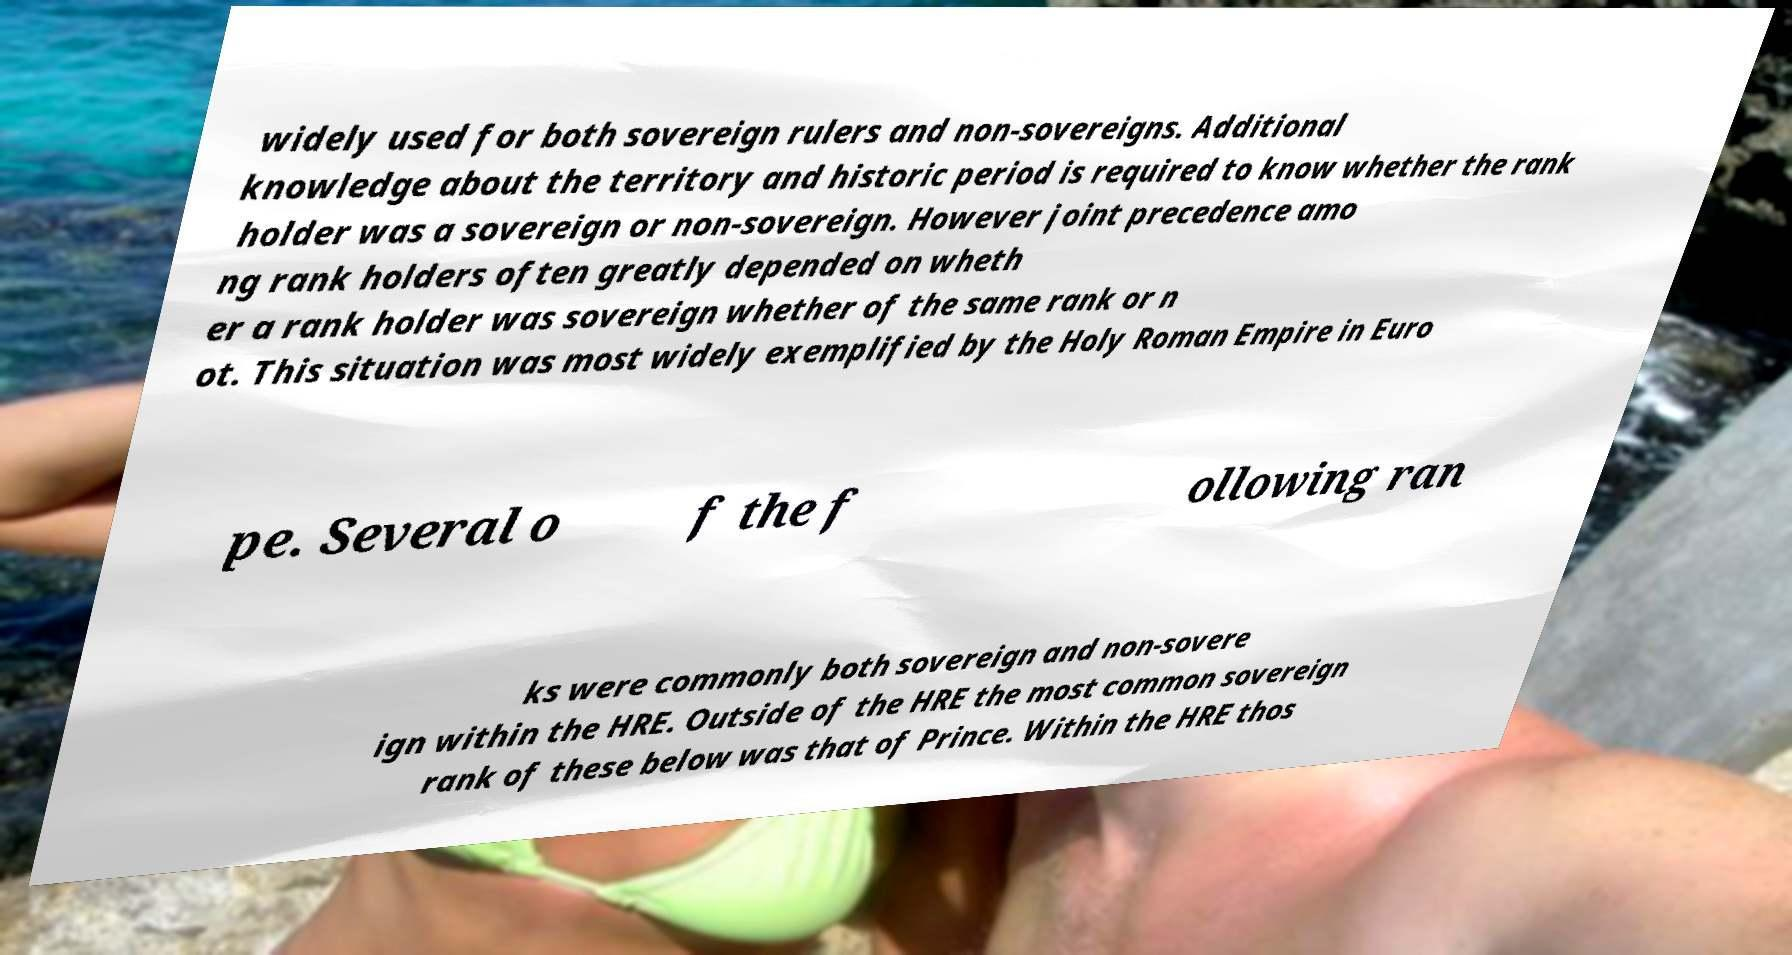For documentation purposes, I need the text within this image transcribed. Could you provide that? widely used for both sovereign rulers and non-sovereigns. Additional knowledge about the territory and historic period is required to know whether the rank holder was a sovereign or non-sovereign. However joint precedence amo ng rank holders often greatly depended on wheth er a rank holder was sovereign whether of the same rank or n ot. This situation was most widely exemplified by the Holy Roman Empire in Euro pe. Several o f the f ollowing ran ks were commonly both sovereign and non-sovere ign within the HRE. Outside of the HRE the most common sovereign rank of these below was that of Prince. Within the HRE thos 